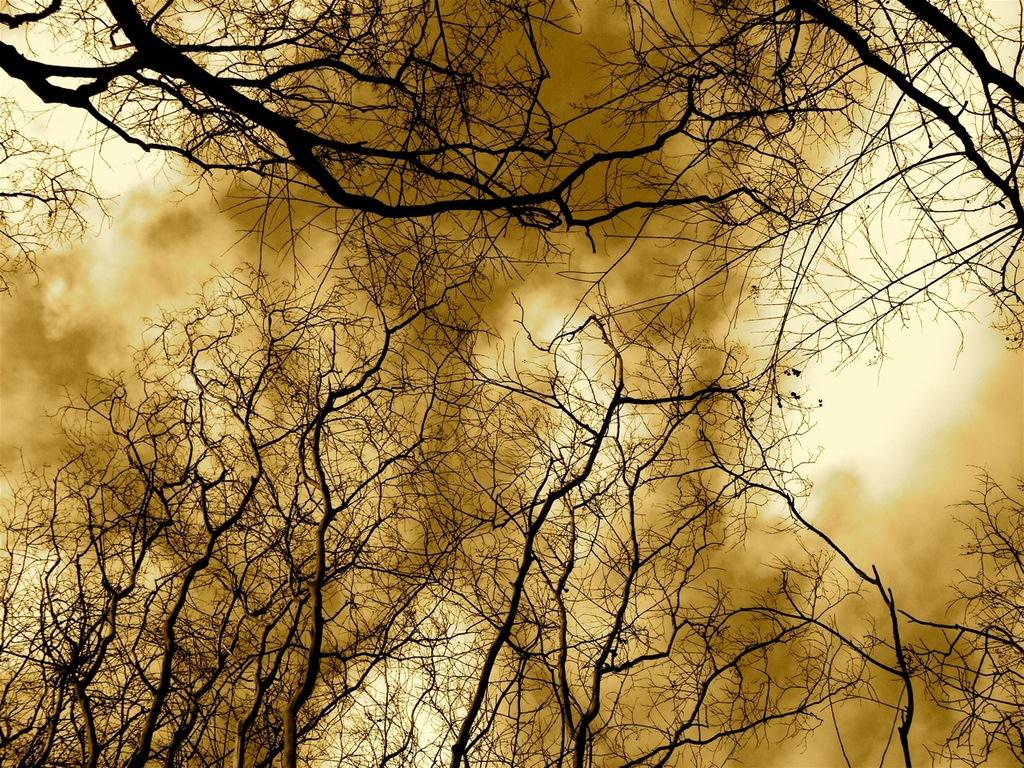What type of vegetation can be seen in the image? There are trees in the image. What is the color of the trees in the image? The trees are black in color. What else is visible in the image besides the trees? There is brown colored smoke in the image. What can be seen in the background of the image? The sky is visible in the background of the image. How many planes are hanging from the trees as ornaments in the image? There are no planes or ornaments present in the image; it features black trees and brown smoke. 